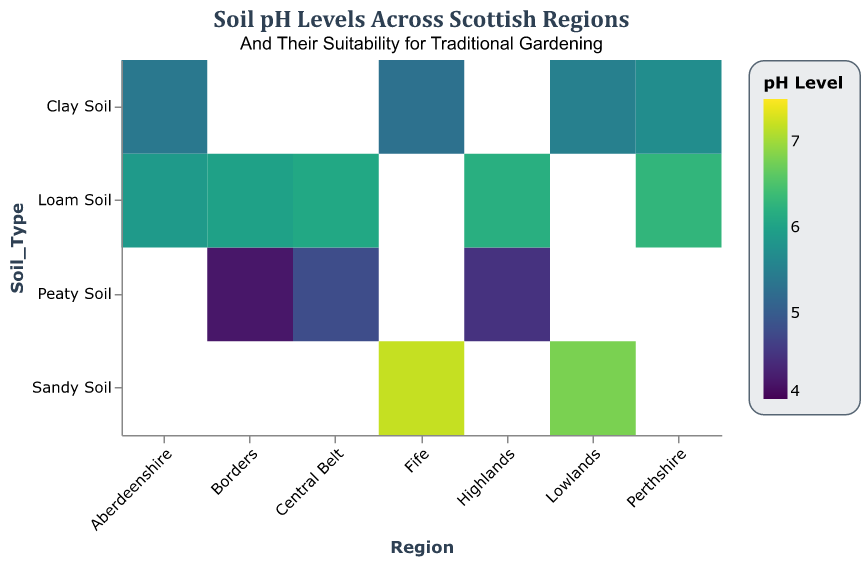What is the pH level range covered in the heatmap? The heatmap depicts soil pH levels ranging from 4.2 to 7.2. The color scale legend on the right helps in identifying the precise range.
Answer: 4.2 to 7.2 Which regions have soil types suitable for traditional gardening classified as 'Excellent'? The tooltip information for 'Suitability for Traditional Gardening' identifies regions with 'Excellent' suitability. These regions are the Highlands (Loam Soil), Lowlands (Sandy Soil), Central Belt (Loam Soil), Fife (Sandy Soil), Borders (Loam Soil), and Perthshire (Loam Soil).
Answer: Highlands, Lowlands, Central Belt, Fife, Borders, Perthshire How many regions have a pH level greater than 6.0 for any soil type? By examining the color coding and tooltip, the regions with soil pH levels above 6.0 are the Highlands (Loam Soil), Lowlands (Sandy Soil), Central Belt (Loam Soil), Fife (Sandy Soil), and Perthshire (Loam Soil), totaling five regions.
Answer: 5 What is the average pH level of Loam Soil across all regions? Sum of pH levels for Loam Soil in all regions involves the Highlands (6.2), Central Belt (6.1), Aberdeenshire (5.9), Borders (6.0), and Perthshire (6.3), giving a total of 30.5. Dividing by the number of regions (5) gives the average: 30.5/5 = 6.1.
Answer: 6.1 Which soil type in the Borders region is least suitable for traditional gardening, based on pH level and suitability? The tooltip indicates that Peaty Soil in the Borders has a pH level of 4.2 and is classified as 'Poor' for traditional gardening, making it the least suitable soil type in that region.
Answer: Peaty Soil What's the difference in pH level between the most suitable soil type in the Highlands and the least suitable soil type in the Highlands? In the Highlands, Loam Soil has the highest suitability with a pH level of 6.2, and Peaty Soil has the lowest with a pH level of 4.5. The difference is 6.2 - 4.5 = 1.7.
Answer: 1.7 Which region has the highest pH level and what is the soil type? The tooltip shows the highest pH level as 7.2 in the Fife region for Sandy Soil.
Answer: Fife, Sandy Soil Is there a region where two different soil types have the same suitability for traditional gardening? The tooltip information reveals that Aberdeenshire has two different soil types—Clay Soil and Loam Soil—both classified as 'Good' for traditional gardening.
Answer: Aberdeenshire What soil type in Perthshire has the highest pH level? The tooltip indicates that among the soil types in Perthshire, Loam Soil has the highest pH level of 6.3.
Answer: Loam Soil 